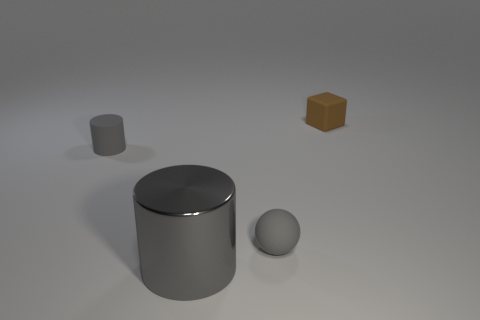There is a cylinder that is in front of the tiny gray thing behind the gray matte thing that is in front of the gray matte cylinder; how big is it?
Offer a very short reply. Large. What number of other things are there of the same color as the small cylinder?
Offer a very short reply. 2. Is the color of the tiny object left of the gray shiny cylinder the same as the big metallic cylinder?
Offer a very short reply. Yes. How many things are tiny rubber balls or big brown cylinders?
Your answer should be very brief. 1. What color is the rubber object that is left of the big metal cylinder?
Keep it short and to the point. Gray. Is the number of large metallic cylinders that are behind the brown rubber thing less than the number of large cyan metallic cubes?
Provide a short and direct response. No. There is a metal object that is the same color as the ball; what size is it?
Your response must be concise. Large. Are there any other things that have the same size as the metal object?
Provide a succinct answer. No. Are the tiny sphere and the small gray cylinder made of the same material?
Make the answer very short. Yes. What number of things are either rubber things in front of the brown rubber thing or rubber things right of the shiny thing?
Provide a succinct answer. 3. 